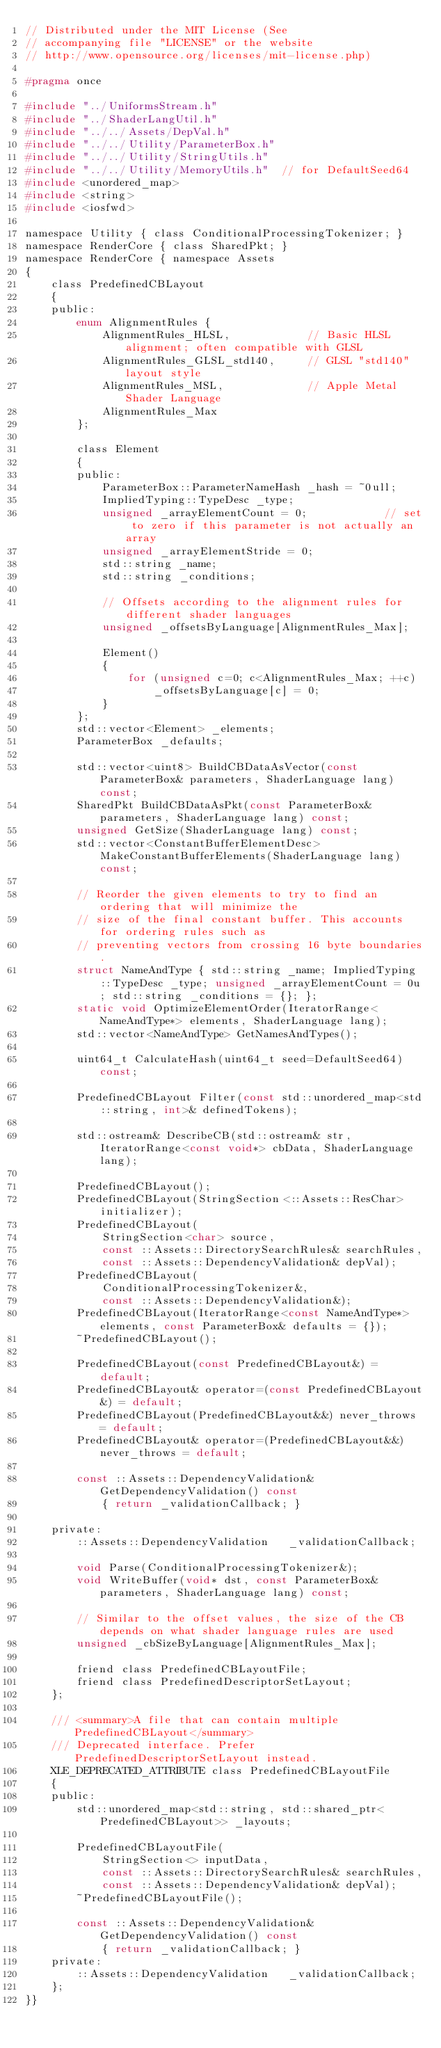<code> <loc_0><loc_0><loc_500><loc_500><_C_>// Distributed under the MIT License (See
// accompanying file "LICENSE" or the website
// http://www.opensource.org/licenses/mit-license.php)

#pragma once

#include "../UniformsStream.h"
#include "../ShaderLangUtil.h"
#include "../../Assets/DepVal.h"
#include "../../Utility/ParameterBox.h"
#include "../../Utility/StringUtils.h"
#include "../../Utility/MemoryUtils.h"	// for DefaultSeed64
#include <unordered_map>
#include <string>
#include <iosfwd>

namespace Utility { class ConditionalProcessingTokenizer; }
namespace RenderCore { class SharedPkt; }
namespace RenderCore { namespace Assets
{
    class PredefinedCBLayout
    {
    public:
        enum AlignmentRules {
            AlignmentRules_HLSL,            // Basic HLSL alignment; often compatible with GLSL
            AlignmentRules_GLSL_std140,     // GLSL "std140" layout style
            AlignmentRules_MSL,             // Apple Metal Shader Language
            AlignmentRules_Max
        };

        class Element
        {
        public:
            ParameterBox::ParameterNameHash _hash = ~0ull;
            ImpliedTyping::TypeDesc _type;
            unsigned _arrayElementCount = 0;            // set to zero if this parameter is not actually an array
            unsigned _arrayElementStride = 0;
            std::string _name;
            std::string _conditions;

            // Offsets according to the alignment rules for different shader languages
            unsigned _offsetsByLanguage[AlignmentRules_Max];

			Element()
			{
				for (unsigned c=0; c<AlignmentRules_Max; ++c)
					_offsetsByLanguage[c] = 0;
			}
        };
        std::vector<Element> _elements;
        ParameterBox _defaults;

        std::vector<uint8> BuildCBDataAsVector(const ParameterBox& parameters, ShaderLanguage lang) const;
        SharedPkt BuildCBDataAsPkt(const ParameterBox& parameters, ShaderLanguage lang) const;
        unsigned GetSize(ShaderLanguage lang) const;
        std::vector<ConstantBufferElementDesc> MakeConstantBufferElements(ShaderLanguage lang) const;

		// Reorder the given elements to try to find an ordering that will minimize the
		// size of the final constant buffer. This accounts for ordering rules such as
		// preventing vectors from crossing 16 byte boundaries.
		struct NameAndType { std::string _name; ImpliedTyping::TypeDesc _type; unsigned _arrayElementCount = 0u; std::string _conditions = {}; };
		static void OptimizeElementOrder(IteratorRange<NameAndType*> elements, ShaderLanguage lang);
        std::vector<NameAndType> GetNamesAndTypes();

        uint64_t CalculateHash(uint64_t seed=DefaultSeed64) const;

        PredefinedCBLayout Filter(const std::unordered_map<std::string, int>& definedTokens);

        std::ostream& DescribeCB(std::ostream& str, IteratorRange<const void*> cbData, ShaderLanguage lang);

        PredefinedCBLayout();
        PredefinedCBLayout(StringSection<::Assets::ResChar> initializer);
        PredefinedCBLayout(
            StringSection<char> source, 
            const ::Assets::DirectorySearchRules& searchRules,
			const ::Assets::DependencyValidation& depVal);
        PredefinedCBLayout(
			ConditionalProcessingTokenizer&,
			const ::Assets::DependencyValidation&);
		PredefinedCBLayout(IteratorRange<const NameAndType*> elements, const ParameterBox& defaults = {});
        ~PredefinedCBLayout();
        
        PredefinedCBLayout(const PredefinedCBLayout&) = default;
        PredefinedCBLayout& operator=(const PredefinedCBLayout&) = default;
        PredefinedCBLayout(PredefinedCBLayout&&) never_throws = default;
        PredefinedCBLayout& operator=(PredefinedCBLayout&&) never_throws = default;

        const ::Assets::DependencyValidation& GetDependencyValidation() const     
            { return _validationCallback; }

    private:
        ::Assets::DependencyValidation   _validationCallback;

        void Parse(ConditionalProcessingTokenizer&);
        void WriteBuffer(void* dst, const ParameterBox& parameters, ShaderLanguage lang) const;

        // Similar to the offset values, the size of the CB depends on what shader language rules are used
        unsigned _cbSizeByLanguage[AlignmentRules_Max];

        friend class PredefinedCBLayoutFile;
		friend class PredefinedDescriptorSetLayout;
    };

	/// <summary>A file that can contain multiple PredefinedCBLayout</summary>
	/// Deprecated interface. Prefer PredefinedDescriptorSetLayout instead.
    XLE_DEPRECATED_ATTRIBUTE class PredefinedCBLayoutFile
    {
    public:
        std::unordered_map<std::string, std::shared_ptr<PredefinedCBLayout>> _layouts;

        PredefinedCBLayoutFile(
            StringSection<> inputData,
            const ::Assets::DirectorySearchRules& searchRules,
            const ::Assets::DependencyValidation& depVal);
        ~PredefinedCBLayoutFile();

        const ::Assets::DependencyValidation& GetDependencyValidation() const
            { return _validationCallback; }
    private:
        ::Assets::DependencyValidation   _validationCallback;
    };
}}
</code> 